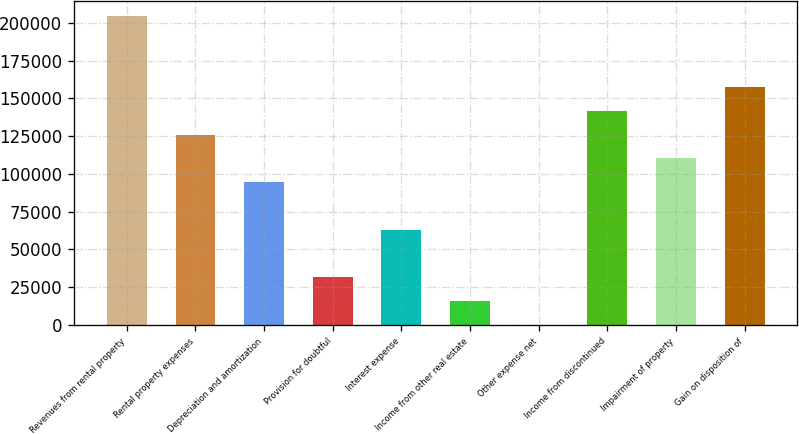<chart> <loc_0><loc_0><loc_500><loc_500><bar_chart><fcel>Revenues from rental property<fcel>Rental property expenses<fcel>Depreciation and amortization<fcel>Provision for doubtful<fcel>Interest expense<fcel>Income from other real estate<fcel>Other expense net<fcel>Income from discontinued<fcel>Impairment of property<fcel>Gain on disposition of<nl><fcel>204637<fcel>126028<fcel>94584.8<fcel>31697.6<fcel>63141.2<fcel>15975.8<fcel>254<fcel>141750<fcel>110307<fcel>157472<nl></chart> 